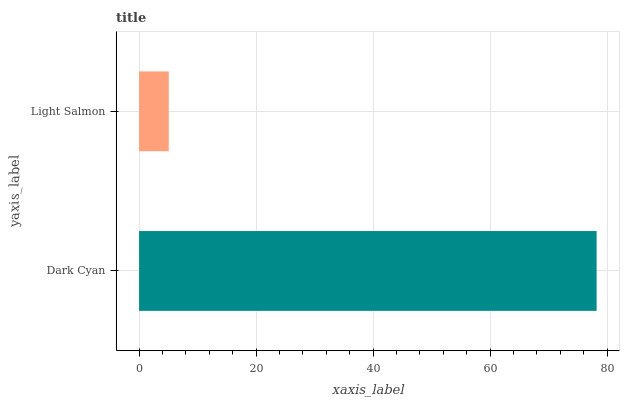Is Light Salmon the minimum?
Answer yes or no. Yes. Is Dark Cyan the maximum?
Answer yes or no. Yes. Is Light Salmon the maximum?
Answer yes or no. No. Is Dark Cyan greater than Light Salmon?
Answer yes or no. Yes. Is Light Salmon less than Dark Cyan?
Answer yes or no. Yes. Is Light Salmon greater than Dark Cyan?
Answer yes or no. No. Is Dark Cyan less than Light Salmon?
Answer yes or no. No. Is Dark Cyan the high median?
Answer yes or no. Yes. Is Light Salmon the low median?
Answer yes or no. Yes. Is Light Salmon the high median?
Answer yes or no. No. Is Dark Cyan the low median?
Answer yes or no. No. 